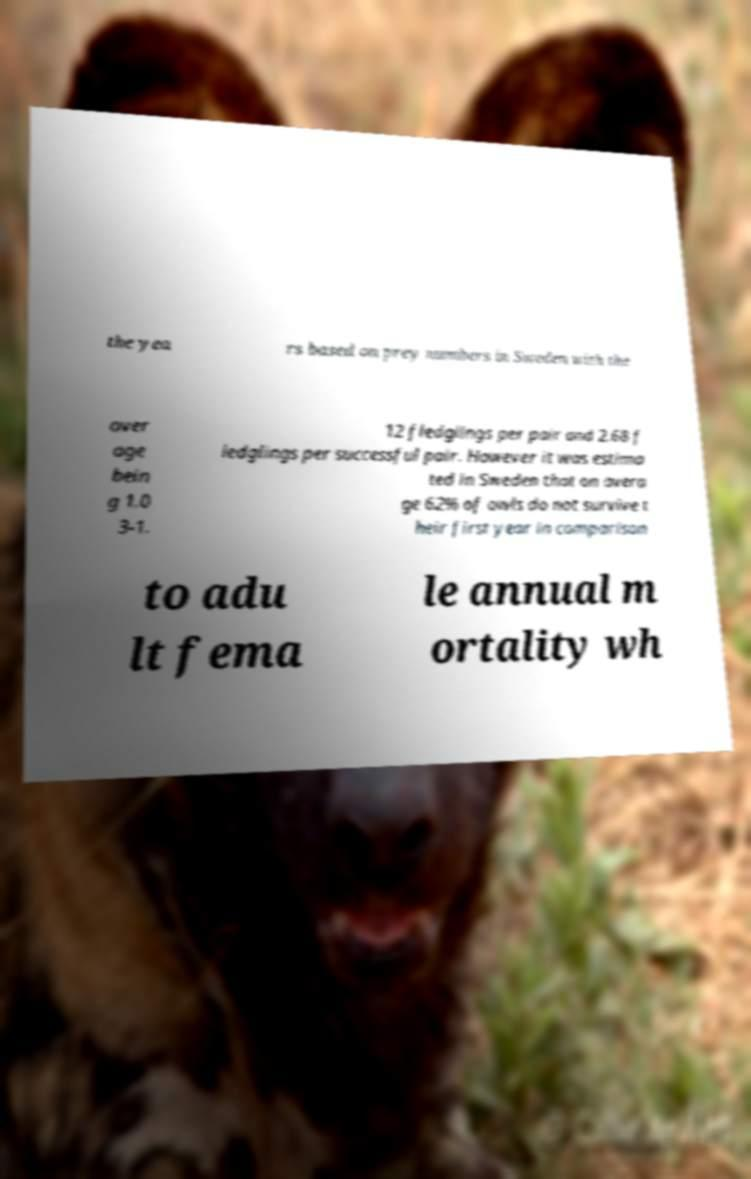Please identify and transcribe the text found in this image. the yea rs based on prey numbers in Sweden with the aver age bein g 1.0 3-1. 12 fledglings per pair and 2.68 f ledglings per successful pair. However it was estima ted in Sweden that on avera ge 62% of owls do not survive t heir first year in comparison to adu lt fema le annual m ortality wh 